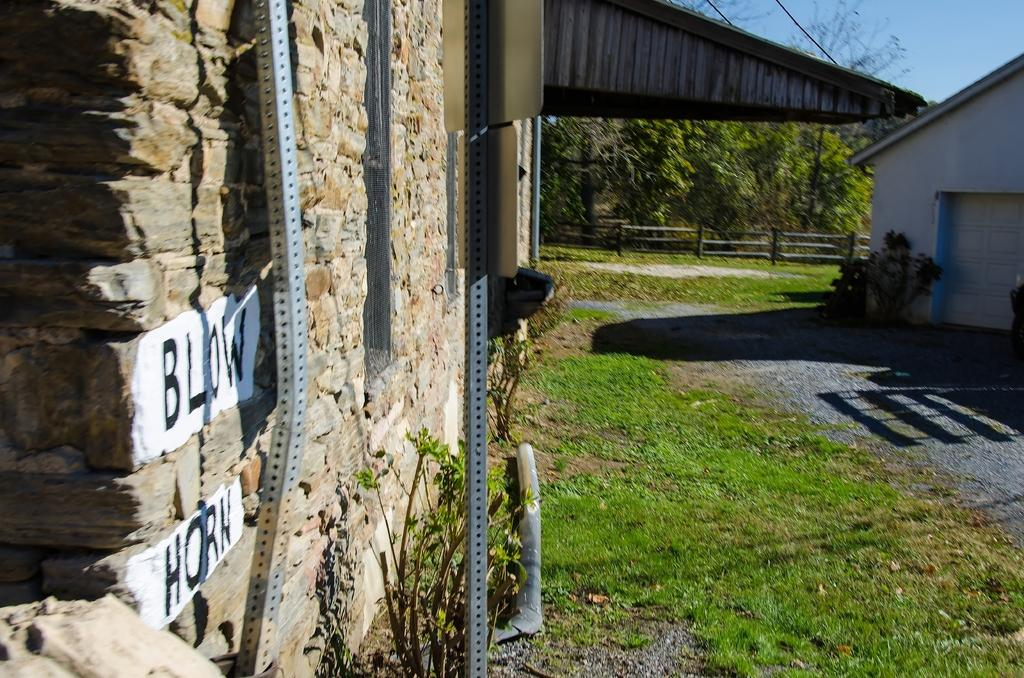What is written or displayed on the wall in the image? There is text on a wall in the image. What type of structures can be seen in the image? Metal poles, a house, and a fence are present in the image. What type of vegetation is visible in the image? Grass, plants, and a group of trees are visible in the image. What part of the natural environment is visible in the image? The sky is visible in the image. How far away is the beggar from the house in the image? There is no beggar present in the image. What type of weather is depicted in the image, such as sleet or rain? The image does not depict any specific weather conditions; it only shows the sky, which is not indicative of any particular weather. 